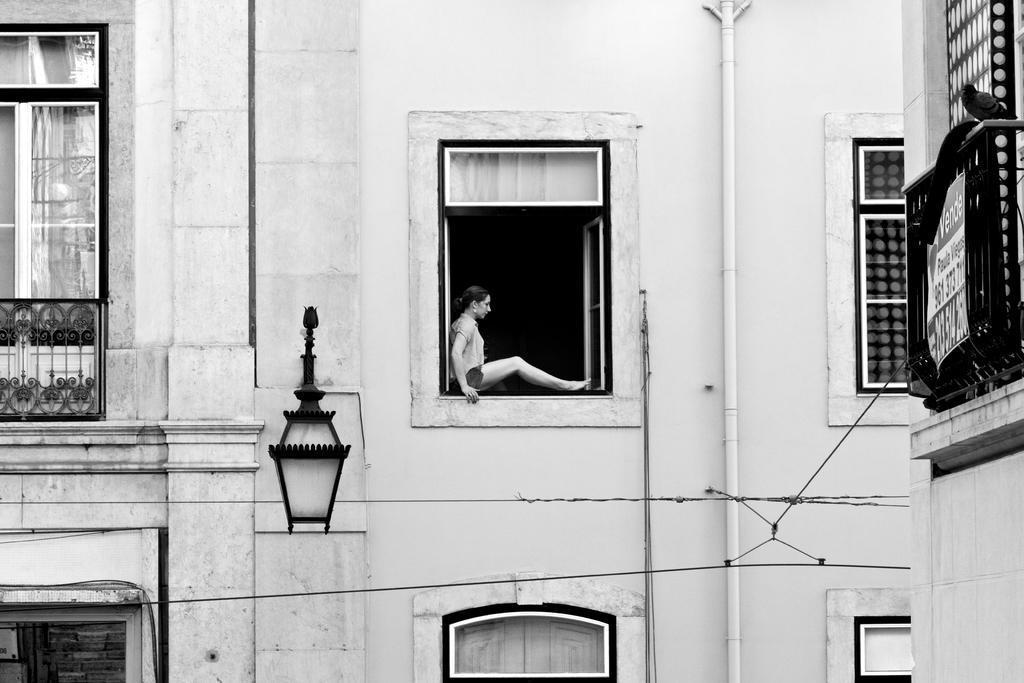In one or two sentences, can you explain what this image depicts? In this image there is a woman sitting on the window of a building. On the building there are glass windows with metal rod balconies and there are lamps, pipes and cables. On the grill there is a display board on top of the grill there is a bird. 